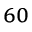Convert formula to latex. <formula><loc_0><loc_0><loc_500><loc_500>_ { 6 0 }</formula> 